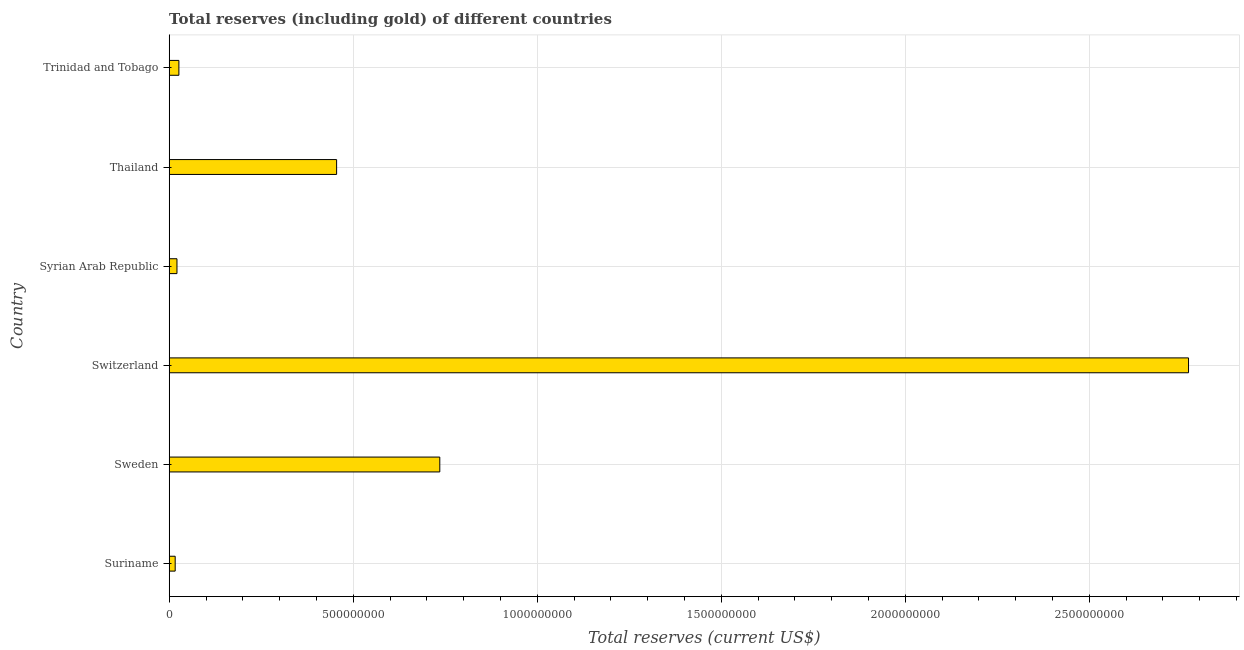Does the graph contain grids?
Your answer should be very brief. Yes. What is the title of the graph?
Offer a terse response. Total reserves (including gold) of different countries. What is the label or title of the X-axis?
Offer a very short reply. Total reserves (current US$). What is the label or title of the Y-axis?
Offer a terse response. Country. What is the total reserves (including gold) in Trinidad and Tobago?
Ensure brevity in your answer.  2.63e+07. Across all countries, what is the maximum total reserves (including gold)?
Your answer should be very brief. 2.77e+09. Across all countries, what is the minimum total reserves (including gold)?
Give a very brief answer. 1.63e+07. In which country was the total reserves (including gold) maximum?
Your answer should be very brief. Switzerland. In which country was the total reserves (including gold) minimum?
Give a very brief answer. Suriname. What is the sum of the total reserves (including gold)?
Your response must be concise. 4.02e+09. What is the difference between the total reserves (including gold) in Switzerland and Syrian Arab Republic?
Ensure brevity in your answer.  2.75e+09. What is the average total reserves (including gold) per country?
Your answer should be very brief. 6.71e+08. What is the median total reserves (including gold)?
Offer a very short reply. 2.41e+08. In how many countries, is the total reserves (including gold) greater than 2100000000 US$?
Your response must be concise. 1. What is the ratio of the total reserves (including gold) in Suriname to that in Thailand?
Ensure brevity in your answer.  0.04. Is the difference between the total reserves (including gold) in Suriname and Switzerland greater than the difference between any two countries?
Your answer should be very brief. Yes. What is the difference between the highest and the second highest total reserves (including gold)?
Keep it short and to the point. 2.03e+09. What is the difference between the highest and the lowest total reserves (including gold)?
Provide a short and direct response. 2.75e+09. How many bars are there?
Provide a short and direct response. 6. What is the difference between two consecutive major ticks on the X-axis?
Make the answer very short. 5.00e+08. Are the values on the major ticks of X-axis written in scientific E-notation?
Your answer should be very brief. No. What is the Total reserves (current US$) of Suriname?
Provide a short and direct response. 1.63e+07. What is the Total reserves (current US$) of Sweden?
Make the answer very short. 7.35e+08. What is the Total reserves (current US$) of Switzerland?
Provide a succinct answer. 2.77e+09. What is the Total reserves (current US$) in Syrian Arab Republic?
Make the answer very short. 2.11e+07. What is the Total reserves (current US$) of Thailand?
Offer a terse response. 4.55e+08. What is the Total reserves (current US$) in Trinidad and Tobago?
Provide a short and direct response. 2.63e+07. What is the difference between the Total reserves (current US$) in Suriname and Sweden?
Offer a very short reply. -7.19e+08. What is the difference between the Total reserves (current US$) in Suriname and Switzerland?
Offer a terse response. -2.75e+09. What is the difference between the Total reserves (current US$) in Suriname and Syrian Arab Republic?
Give a very brief answer. -4.82e+06. What is the difference between the Total reserves (current US$) in Suriname and Thailand?
Your response must be concise. -4.39e+08. What is the difference between the Total reserves (current US$) in Suriname and Trinidad and Tobago?
Offer a terse response. -1.00e+07. What is the difference between the Total reserves (current US$) in Sweden and Switzerland?
Offer a very short reply. -2.03e+09. What is the difference between the Total reserves (current US$) in Sweden and Syrian Arab Republic?
Your response must be concise. 7.14e+08. What is the difference between the Total reserves (current US$) in Sweden and Thailand?
Make the answer very short. 2.80e+08. What is the difference between the Total reserves (current US$) in Sweden and Trinidad and Tobago?
Offer a terse response. 7.09e+08. What is the difference between the Total reserves (current US$) in Switzerland and Syrian Arab Republic?
Ensure brevity in your answer.  2.75e+09. What is the difference between the Total reserves (current US$) in Switzerland and Thailand?
Your answer should be very brief. 2.31e+09. What is the difference between the Total reserves (current US$) in Switzerland and Trinidad and Tobago?
Your answer should be very brief. 2.74e+09. What is the difference between the Total reserves (current US$) in Syrian Arab Republic and Thailand?
Your answer should be compact. -4.34e+08. What is the difference between the Total reserves (current US$) in Syrian Arab Republic and Trinidad and Tobago?
Your answer should be compact. -5.21e+06. What is the difference between the Total reserves (current US$) in Thailand and Trinidad and Tobago?
Provide a succinct answer. 4.29e+08. What is the ratio of the Total reserves (current US$) in Suriname to that in Sweden?
Your answer should be compact. 0.02. What is the ratio of the Total reserves (current US$) in Suriname to that in Switzerland?
Ensure brevity in your answer.  0.01. What is the ratio of the Total reserves (current US$) in Suriname to that in Syrian Arab Republic?
Give a very brief answer. 0.77. What is the ratio of the Total reserves (current US$) in Suriname to that in Thailand?
Keep it short and to the point. 0.04. What is the ratio of the Total reserves (current US$) in Suriname to that in Trinidad and Tobago?
Your answer should be compact. 0.62. What is the ratio of the Total reserves (current US$) in Sweden to that in Switzerland?
Make the answer very short. 0.27. What is the ratio of the Total reserves (current US$) in Sweden to that in Syrian Arab Republic?
Make the answer very short. 34.87. What is the ratio of the Total reserves (current US$) in Sweden to that in Thailand?
Provide a succinct answer. 1.62. What is the ratio of the Total reserves (current US$) in Sweden to that in Trinidad and Tobago?
Your response must be concise. 27.96. What is the ratio of the Total reserves (current US$) in Switzerland to that in Syrian Arab Republic?
Provide a succinct answer. 131.36. What is the ratio of the Total reserves (current US$) in Switzerland to that in Thailand?
Your answer should be compact. 6.09. What is the ratio of the Total reserves (current US$) in Switzerland to that in Trinidad and Tobago?
Make the answer very short. 105.32. What is the ratio of the Total reserves (current US$) in Syrian Arab Republic to that in Thailand?
Your answer should be very brief. 0.05. What is the ratio of the Total reserves (current US$) in Syrian Arab Republic to that in Trinidad and Tobago?
Keep it short and to the point. 0.8. What is the ratio of the Total reserves (current US$) in Thailand to that in Trinidad and Tobago?
Offer a terse response. 17.3. 